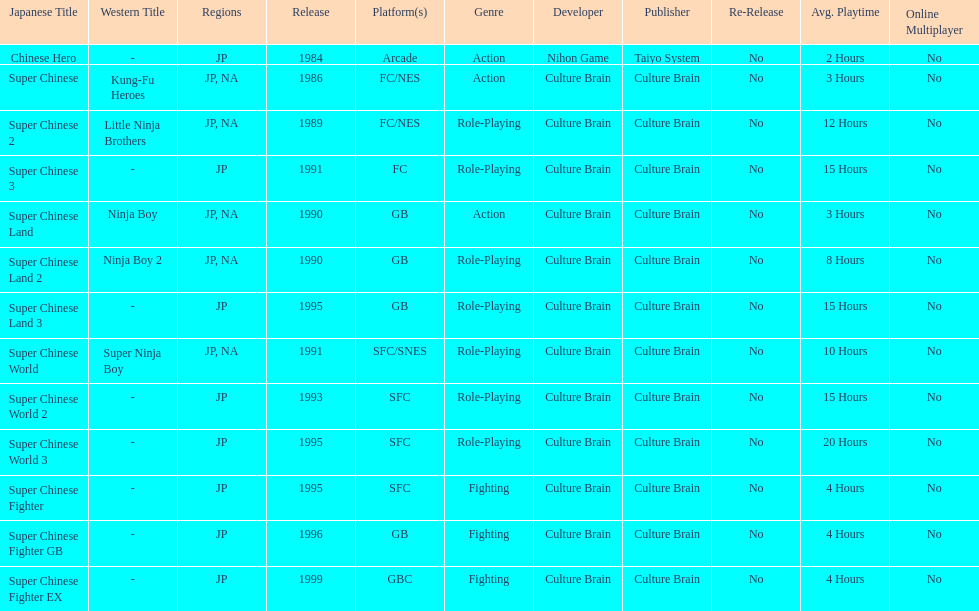What are the total of super chinese games released? 13. 